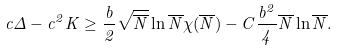Convert formula to latex. <formula><loc_0><loc_0><loc_500><loc_500>c \Delta - c ^ { 2 } K \geq \frac { b } { 2 } \sqrt { \overline { N } } \ln \overline { N } \chi ( \overline { N } ) - C \frac { b ^ { 2 } } { 4 } \overline { N } \ln \overline { N } .</formula> 